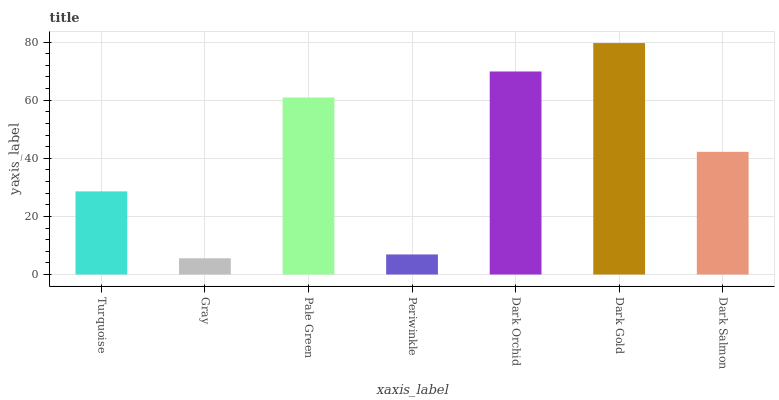Is Pale Green the minimum?
Answer yes or no. No. Is Pale Green the maximum?
Answer yes or no. No. Is Pale Green greater than Gray?
Answer yes or no. Yes. Is Gray less than Pale Green?
Answer yes or no. Yes. Is Gray greater than Pale Green?
Answer yes or no. No. Is Pale Green less than Gray?
Answer yes or no. No. Is Dark Salmon the high median?
Answer yes or no. Yes. Is Dark Salmon the low median?
Answer yes or no. Yes. Is Dark Orchid the high median?
Answer yes or no. No. Is Dark Gold the low median?
Answer yes or no. No. 